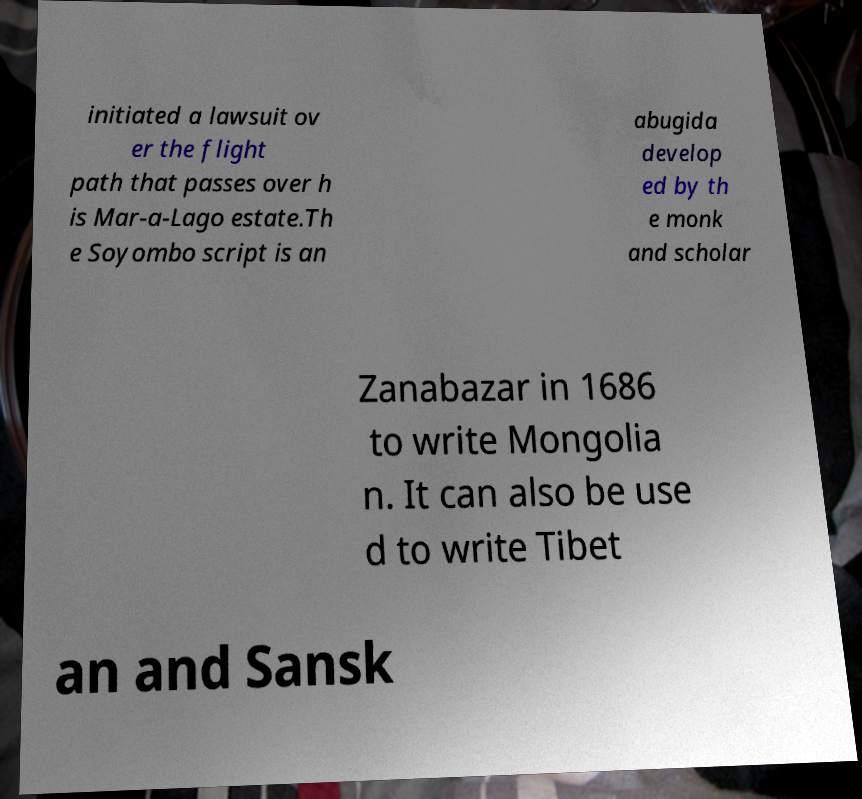Could you extract and type out the text from this image? initiated a lawsuit ov er the flight path that passes over h is Mar-a-Lago estate.Th e Soyombo script is an abugida develop ed by th e monk and scholar Zanabazar in 1686 to write Mongolia n. It can also be use d to write Tibet an and Sansk 